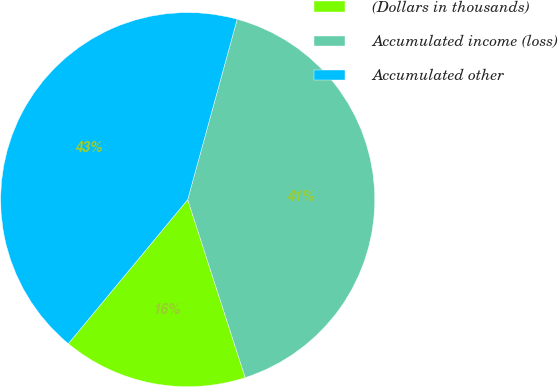Convert chart. <chart><loc_0><loc_0><loc_500><loc_500><pie_chart><fcel>(Dollars in thousands)<fcel>Accumulated income (loss)<fcel>Accumulated other<nl><fcel>15.99%<fcel>40.77%<fcel>43.25%<nl></chart> 